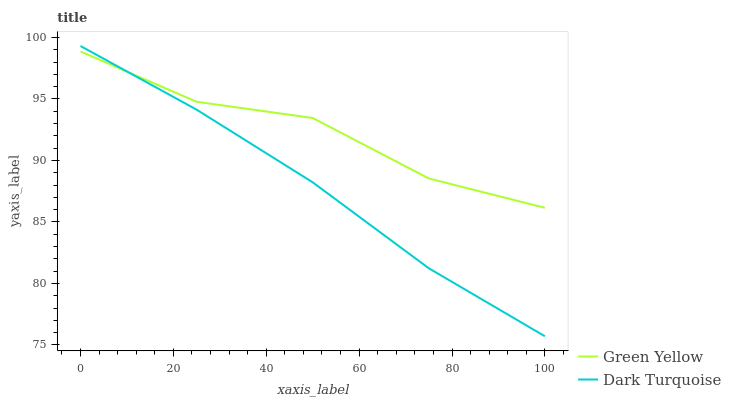Does Green Yellow have the minimum area under the curve?
Answer yes or no. No. Is Green Yellow the smoothest?
Answer yes or no. No. Does Green Yellow have the lowest value?
Answer yes or no. No. Does Green Yellow have the highest value?
Answer yes or no. No. 